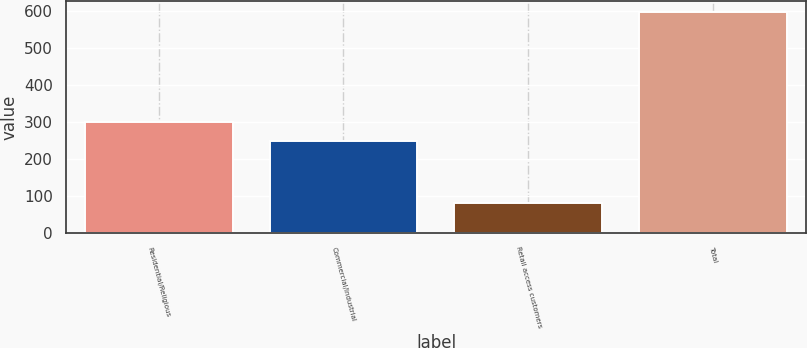<chart> <loc_0><loc_0><loc_500><loc_500><bar_chart><fcel>Residential/Religious<fcel>Commercial/Industrial<fcel>Retail access customers<fcel>Total<nl><fcel>299.5<fcel>248<fcel>81<fcel>596<nl></chart> 